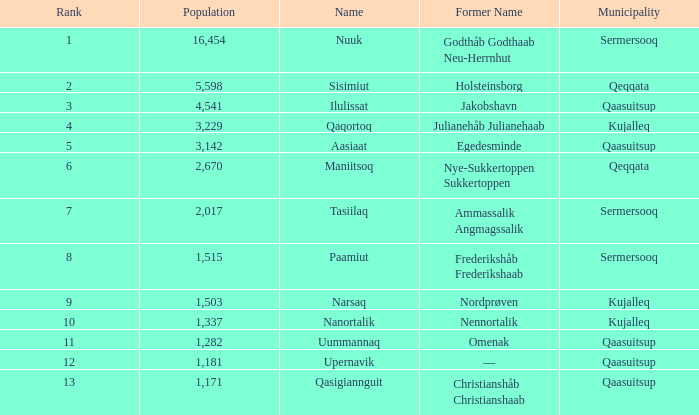Who previously held the name nordprøven? Narsaq. Could you help me parse every detail presented in this table? {'header': ['Rank', 'Population', 'Name', 'Former Name', 'Municipality'], 'rows': [['1', '16,454', 'Nuuk', 'Godthåb Godthaab Neu-Herrnhut', 'Sermersooq'], ['2', '5,598', 'Sisimiut', 'Holsteinsborg', 'Qeqqata'], ['3', '4,541', 'Ilulissat', 'Jakobshavn', 'Qaasuitsup'], ['4', '3,229', 'Qaqortoq', 'Julianehåb Julianehaab', 'Kujalleq'], ['5', '3,142', 'Aasiaat', 'Egedesminde', 'Qaasuitsup'], ['6', '2,670', 'Maniitsoq', 'Nye-Sukkertoppen Sukkertoppen', 'Qeqqata'], ['7', '2,017', 'Tasiilaq', 'Ammassalik Angmagssalik', 'Sermersooq'], ['8', '1,515', 'Paamiut', 'Frederikshåb Frederikshaab', 'Sermersooq'], ['9', '1,503', 'Narsaq', 'Nordprøven', 'Kujalleq'], ['10', '1,337', 'Nanortalik', 'Nennortalik', 'Kujalleq'], ['11', '1,282', 'Uummannaq', 'Omenak', 'Qaasuitsup'], ['12', '1,181', 'Upernavik', '—', 'Qaasuitsup'], ['13', '1,171', 'Qasigiannguit', 'Christianshåb Christianshaab', 'Qaasuitsup']]} 